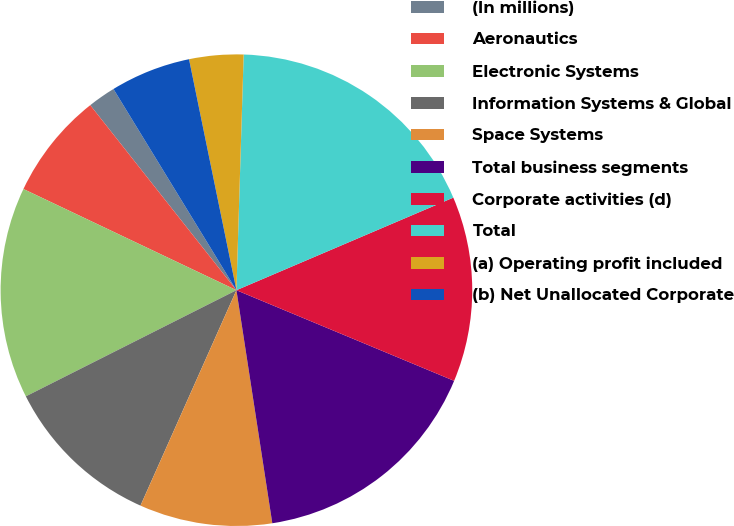Convert chart to OTSL. <chart><loc_0><loc_0><loc_500><loc_500><pie_chart><fcel>(In millions)<fcel>Aeronautics<fcel>Electronic Systems<fcel>Information Systems & Global<fcel>Space Systems<fcel>Total business segments<fcel>Corporate activities (d)<fcel>Total<fcel>(a) Operating profit included<fcel>(b) Net Unallocated Corporate<nl><fcel>1.91%<fcel>7.3%<fcel>14.49%<fcel>10.9%<fcel>9.1%<fcel>16.29%<fcel>12.7%<fcel>18.09%<fcel>3.71%<fcel>5.51%<nl></chart> 